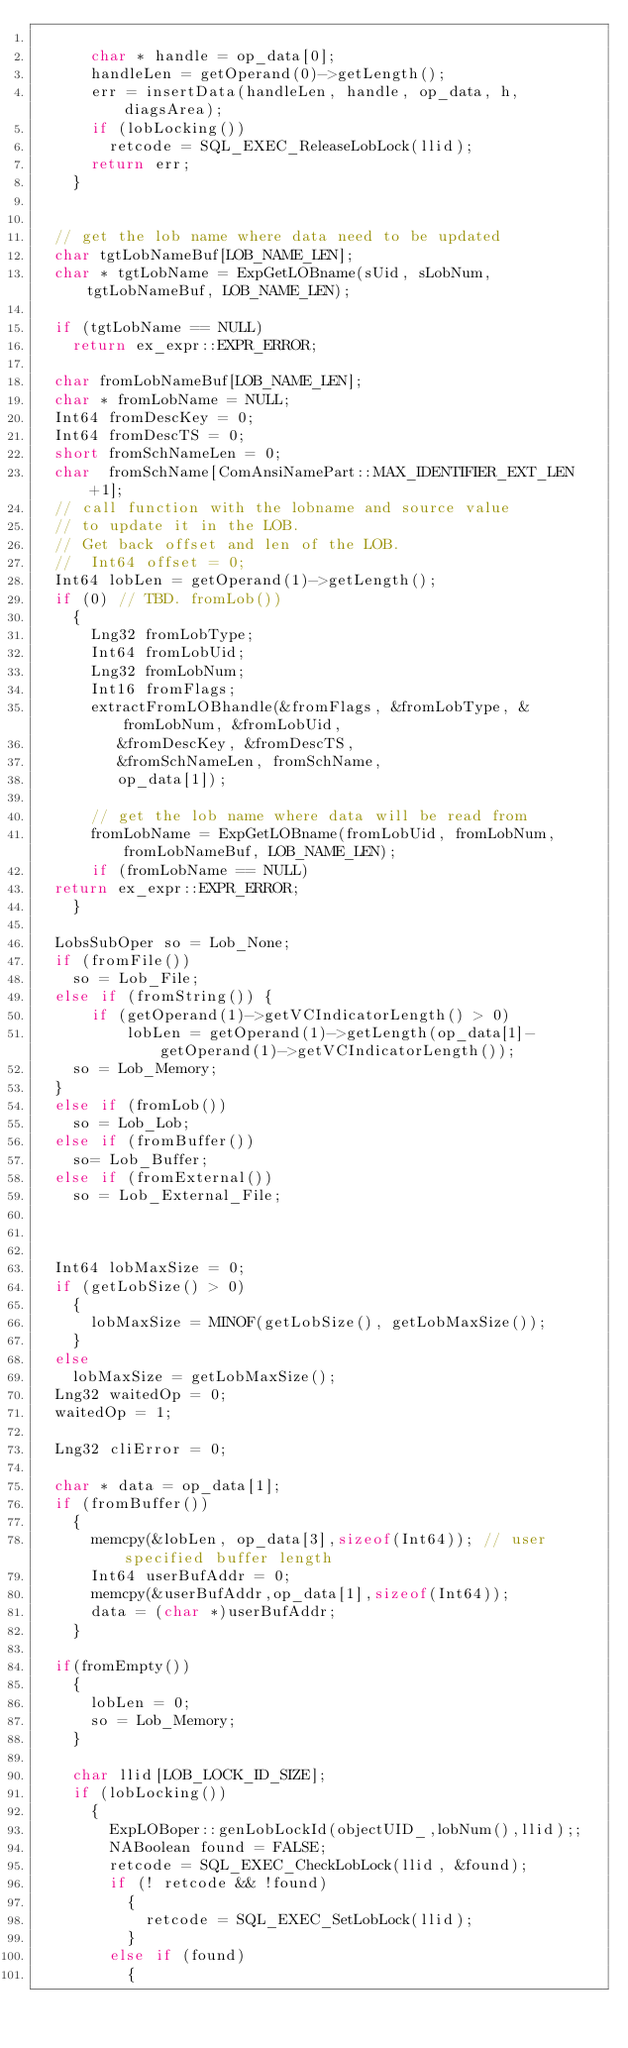<code> <loc_0><loc_0><loc_500><loc_500><_C++_>     
      char * handle = op_data[0];
      handleLen = getOperand(0)->getLength();
      err = insertData(handleLen, handle, op_data, h, diagsArea);
      if (lobLocking())
        retcode = SQL_EXEC_ReleaseLobLock(llid);
      return err;
    }

  
  // get the lob name where data need to be updated
  char tgtLobNameBuf[LOB_NAME_LEN];
  char * tgtLobName = ExpGetLOBname(sUid, sLobNum, tgtLobNameBuf, LOB_NAME_LEN);

  if (tgtLobName == NULL)
    return ex_expr::EXPR_ERROR;

  char fromLobNameBuf[LOB_NAME_LEN];
  char * fromLobName = NULL;
  Int64 fromDescKey = 0;
  Int64 fromDescTS = 0;
  short fromSchNameLen = 0;
  char  fromSchName[ComAnsiNamePart::MAX_IDENTIFIER_EXT_LEN+1];
  // call function with the lobname and source value
  // to update it in the LOB.
  // Get back offset and len of the LOB.
  //  Int64 offset = 0;
  Int64 lobLen = getOperand(1)->getLength();
  if (0) // TBD. fromLob())
    {
      Lng32 fromLobType;
      Int64 fromLobUid;
      Lng32 fromLobNum;
      Int16 fromFlags;
      extractFromLOBhandle(&fromFlags, &fromLobType, &fromLobNum, &fromLobUid,
			   &fromDescKey, &fromDescTS, 
			   &fromSchNameLen, fromSchName,
			   op_data[1]);

      // get the lob name where data will be read from
      fromLobName = ExpGetLOBname(fromLobUid, fromLobNum, fromLobNameBuf, LOB_NAME_LEN);
      if (fromLobName == NULL)
	return ex_expr::EXPR_ERROR;
    }

  LobsSubOper so = Lob_None;
  if (fromFile())
    so = Lob_File;
  else if (fromString()) {
      if (getOperand(1)->getVCIndicatorLength() > 0)
          lobLen = getOperand(1)->getLength(op_data[1]-getOperand(1)->getVCIndicatorLength());
    so = Lob_Memory;
  }
  else if (fromLob())
    so = Lob_Lob;
  else if (fromBuffer())
    so= Lob_Buffer;
  else if (fromExternal())
    so = Lob_External_File;
 
   
 
  Int64 lobMaxSize = 0;
  if (getLobSize() > 0)
    {
      lobMaxSize = MINOF(getLobSize(), getLobMaxSize());
    }
  else
    lobMaxSize = getLobMaxSize();
  Lng32 waitedOp = 0;
  waitedOp = 1;

  Lng32 cliError = 0;

  char * data = op_data[1];
  if (fromBuffer())
    {
      memcpy(&lobLen, op_data[3],sizeof(Int64)); // user specified buffer length
      Int64 userBufAddr = 0;
      memcpy(&userBufAddr,op_data[1],sizeof(Int64));
      data = (char *)userBufAddr;
    }

  if(fromEmpty())
    {
      lobLen = 0;
      so = Lob_Memory;
    }

    char llid[LOB_LOCK_ID_SIZE];
    if (lobLocking())
      {
        ExpLOBoper::genLobLockId(objectUID_,lobNum(),llid);;
        NABoolean found = FALSE;
        retcode = SQL_EXEC_CheckLobLock(llid, &found);
        if (! retcode && !found) 
          {    
            retcode = SQL_EXEC_SetLobLock(llid);
          }
        else if (found)
          {</code> 